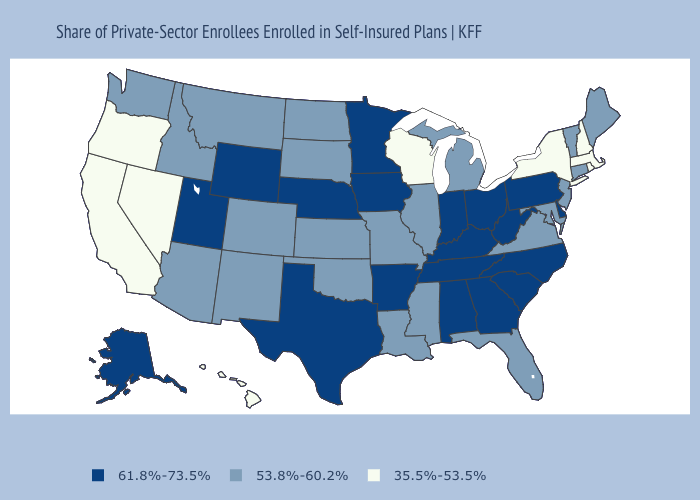Which states have the lowest value in the South?
Answer briefly. Florida, Louisiana, Maryland, Mississippi, Oklahoma, Virginia. Which states hav the highest value in the South?
Write a very short answer. Alabama, Arkansas, Delaware, Georgia, Kentucky, North Carolina, South Carolina, Tennessee, Texas, West Virginia. Does Utah have the highest value in the West?
Answer briefly. Yes. What is the value of Mississippi?
Short answer required. 53.8%-60.2%. Among the states that border Alabama , which have the highest value?
Be succinct. Georgia, Tennessee. Among the states that border Delaware , does New Jersey have the lowest value?
Answer briefly. Yes. Name the states that have a value in the range 61.8%-73.5%?
Keep it brief. Alabama, Alaska, Arkansas, Delaware, Georgia, Indiana, Iowa, Kentucky, Minnesota, Nebraska, North Carolina, Ohio, Pennsylvania, South Carolina, Tennessee, Texas, Utah, West Virginia, Wyoming. What is the highest value in states that border Maine?
Keep it brief. 35.5%-53.5%. What is the highest value in the USA?
Short answer required. 61.8%-73.5%. What is the value of Vermont?
Quick response, please. 53.8%-60.2%. Which states have the lowest value in the USA?
Write a very short answer. California, Hawaii, Massachusetts, Nevada, New Hampshire, New York, Oregon, Rhode Island, Wisconsin. Does Colorado have the same value as Washington?
Write a very short answer. Yes. What is the lowest value in states that border Idaho?
Be succinct. 35.5%-53.5%. What is the highest value in states that border California?
Give a very brief answer. 53.8%-60.2%. 